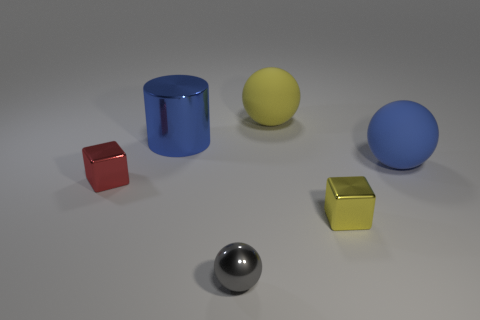Are there any small red cubes on the left side of the blue rubber sphere?
Your response must be concise. Yes. There is a big yellow matte thing; is it the same shape as the blue thing that is right of the blue shiny cylinder?
Your answer should be compact. Yes. How many other objects are there of the same material as the large blue cylinder?
Provide a succinct answer. 3. The block on the left side of the large blue object to the left of the big blue thing to the right of the gray object is what color?
Ensure brevity in your answer.  Red. What is the shape of the big rubber object that is in front of the blue cylinder to the right of the red cube?
Your response must be concise. Sphere. Is the number of cubes to the right of the small red object greater than the number of small green cylinders?
Your answer should be very brief. Yes. Do the thing that is right of the small yellow metal object and the gray shiny thing have the same shape?
Make the answer very short. Yes. Is there a gray metal object that has the same shape as the blue matte thing?
Give a very brief answer. Yes. What number of objects are either large spheres behind the blue cylinder or small red shiny things?
Ensure brevity in your answer.  2. Are there more tiny gray shiny balls than small green rubber cylinders?
Provide a short and direct response. Yes. 